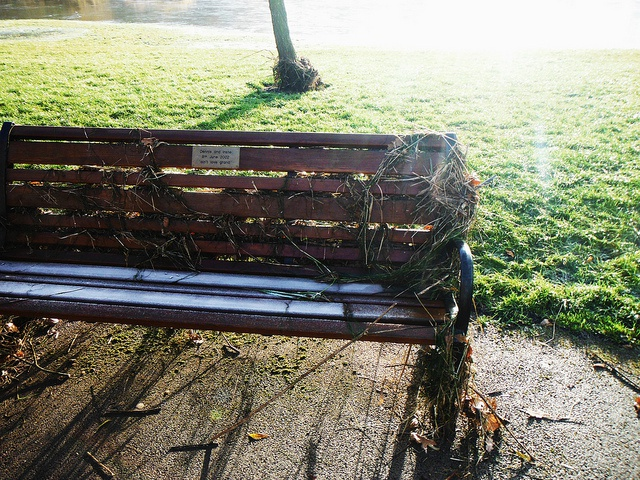Describe the objects in this image and their specific colors. I can see a bench in gray, black, and darkgray tones in this image. 